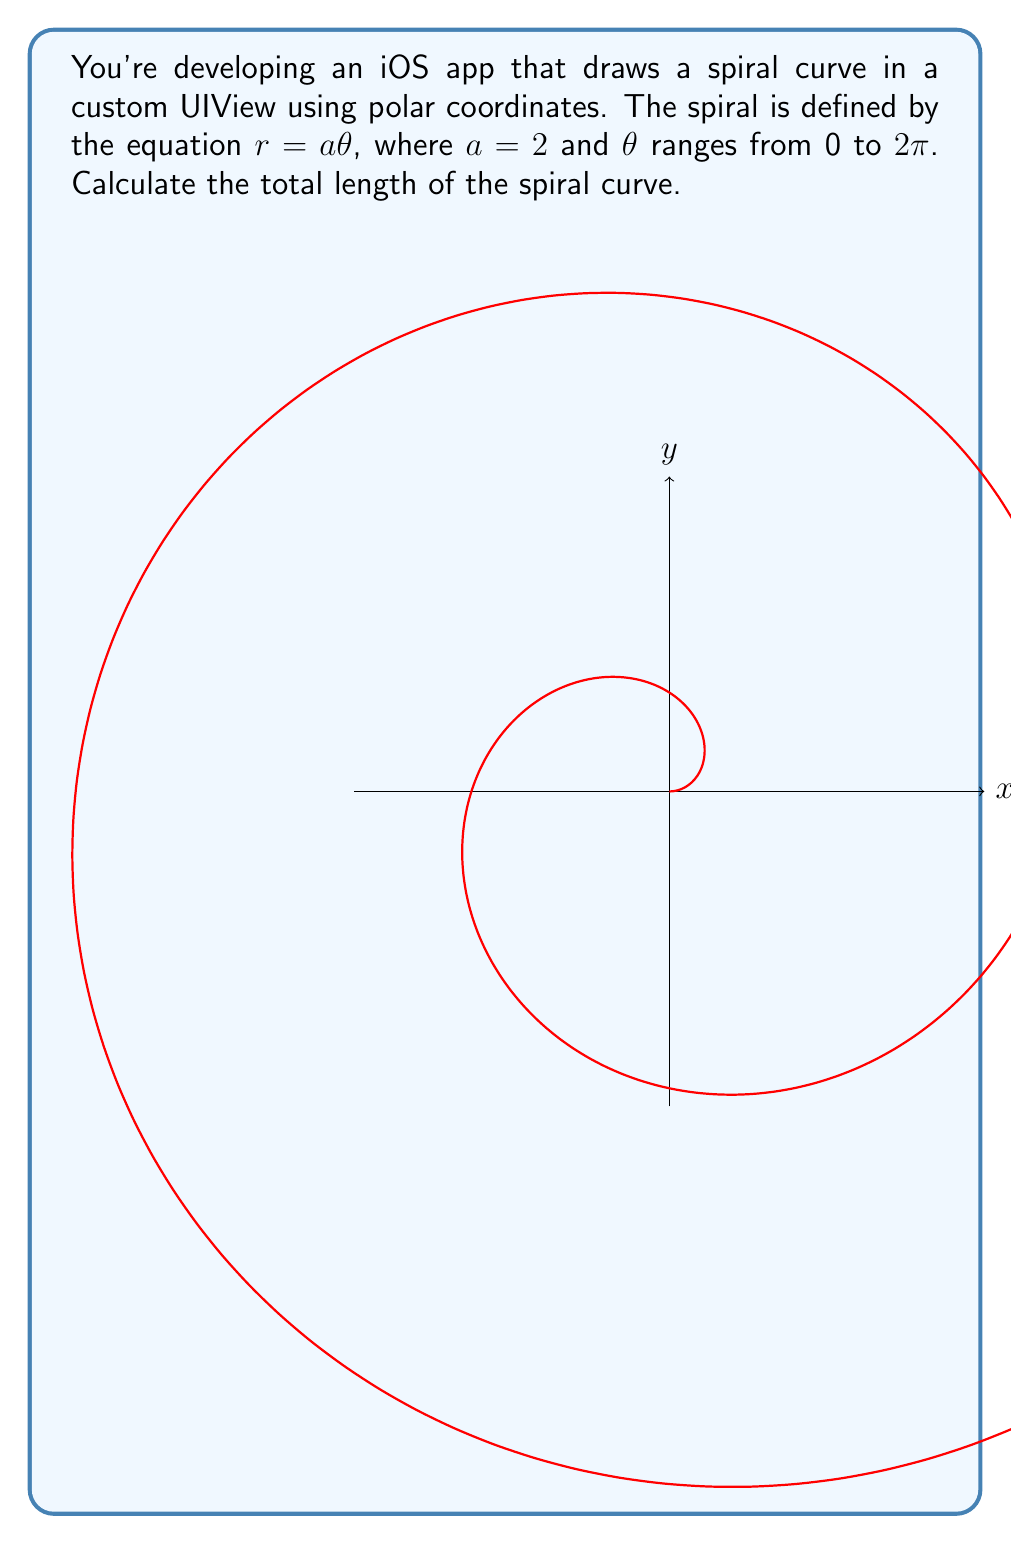Provide a solution to this math problem. To calculate the length of the spiral curve, we'll follow these steps:

1) The formula for the length of a curve in polar coordinates is:

   $$L = \int_{\theta_1}^{\theta_2} \sqrt{r^2 + \left(\frac{dr}{d\theta}\right)^2} d\theta$$

2) We're given $r = a\theta$ where $a = 2$, so:
   
   $$r = 2\theta$$
   $$\frac{dr}{d\theta} = 2$$

3) Substituting these into the length formula:

   $$L = \int_0^{2\pi} \sqrt{(2\theta)^2 + 2^2} d\theta$$

4) Simplify inside the square root:

   $$L = \int_0^{2\pi} \sqrt{4\theta^2 + 4} d\theta$$
   $$L = 2\int_0^{2\pi} \sqrt{\theta^2 + 1} d\theta$$

5) This integral doesn't have an elementary antiderivative. We can solve it using the substitution $\theta = \sinh u$:

   $$L = 2\int_0^{\sinh^{-1}(2\pi)} \sqrt{\sinh^2 u + 1} \cosh u du$$

6) Recall that $\sinh^2 u + 1 = \cosh^2 u$:

   $$L = 2\int_0^{\sinh^{-1}(2\pi)} \cosh^2 u du$$

7) The antiderivative of $\cosh^2 u$ is $\frac{1}{4}(2u + \sinh 2u)$, so:

   $$L = 2\left[\frac{1}{4}(2u + \sinh 2u)\right]_0^{\sinh^{-1}(2\pi)}$$

8) Evaluating the bounds:

   $$L = \frac{1}{2}(2\sinh^{-1}(2\pi) + \sinh(2\sinh^{-1}(2\pi))) - 0$$

9) Simplify using the identity $\sinh(2\sinh^{-1}x) = 2x\sqrt{1+x^2}$:

   $$L = \sinh^{-1}(2\pi) + 2\pi\sqrt{1+(2\pi)^2}$$

This is the exact length of the spiral curve. For practical purposes in iOS development, you might want to calculate this numerically.
Answer: $\sinh^{-1}(2\pi) + 2\pi\sqrt{1+(2\pi)^2}$ 